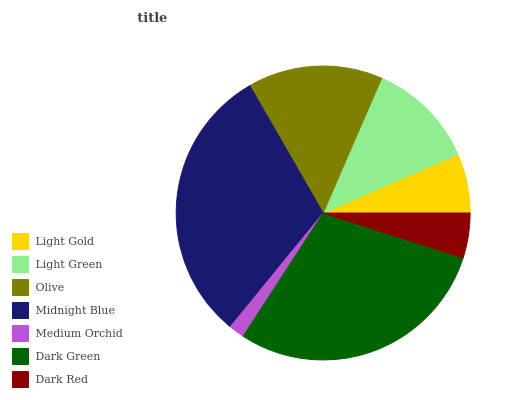Is Medium Orchid the minimum?
Answer yes or no. Yes. Is Midnight Blue the maximum?
Answer yes or no. Yes. Is Light Green the minimum?
Answer yes or no. No. Is Light Green the maximum?
Answer yes or no. No. Is Light Green greater than Light Gold?
Answer yes or no. Yes. Is Light Gold less than Light Green?
Answer yes or no. Yes. Is Light Gold greater than Light Green?
Answer yes or no. No. Is Light Green less than Light Gold?
Answer yes or no. No. Is Light Green the high median?
Answer yes or no. Yes. Is Light Green the low median?
Answer yes or no. Yes. Is Dark Green the high median?
Answer yes or no. No. Is Light Gold the low median?
Answer yes or no. No. 